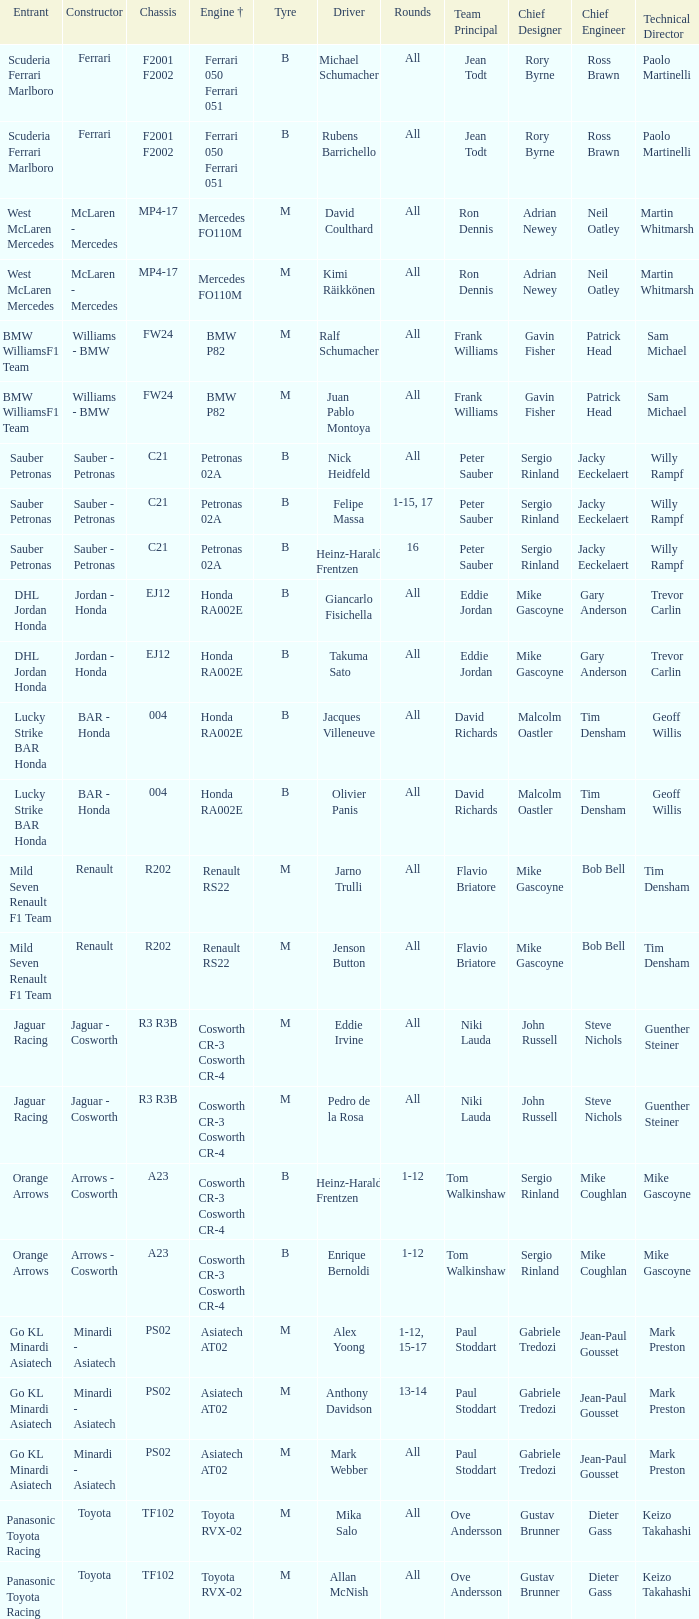What is the rounds when the engine is mercedes fo110m? All, All. 